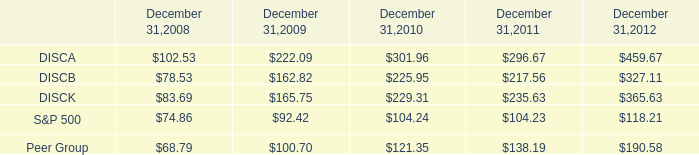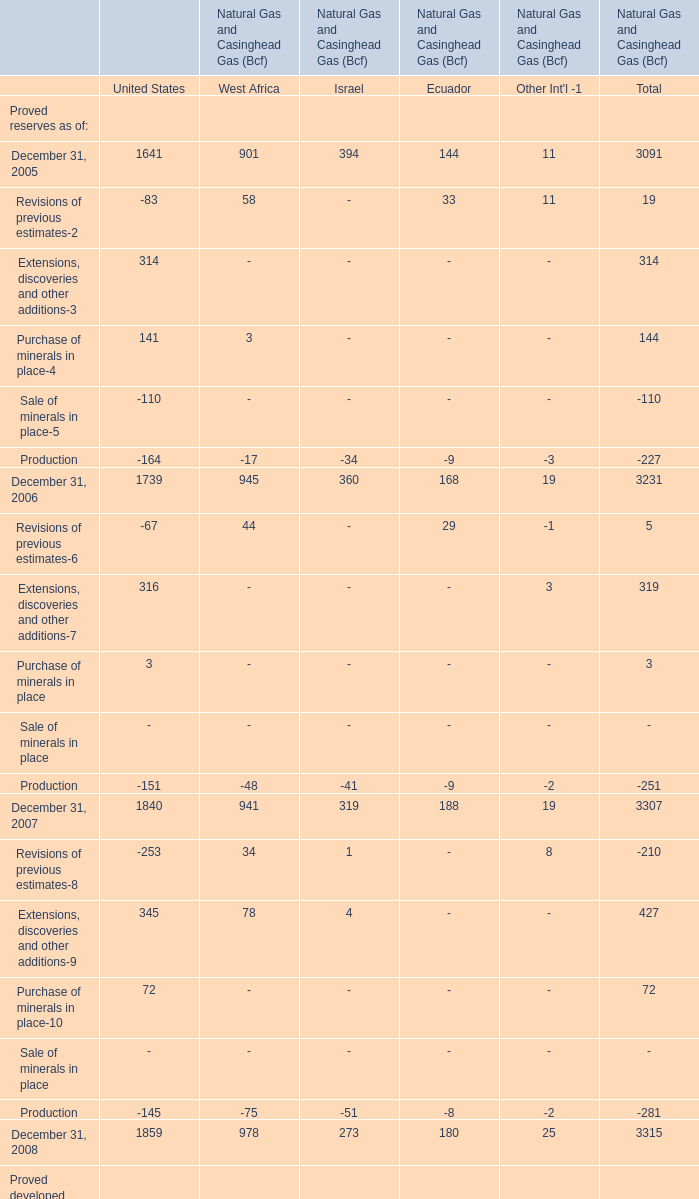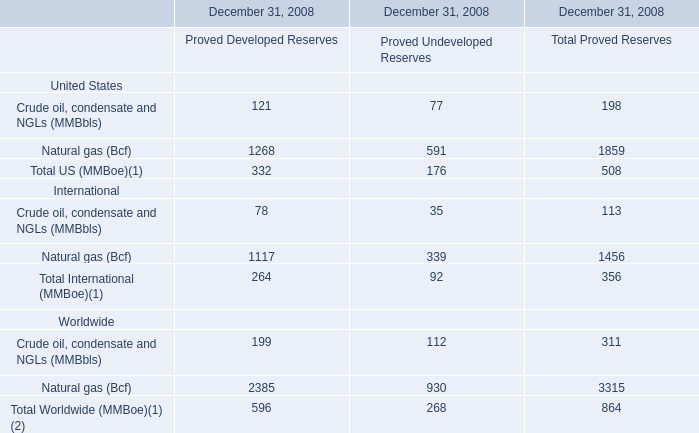Which section is Extensions, discoveries and other additions-9 in 2007 the highest? 
Answer: United States. 